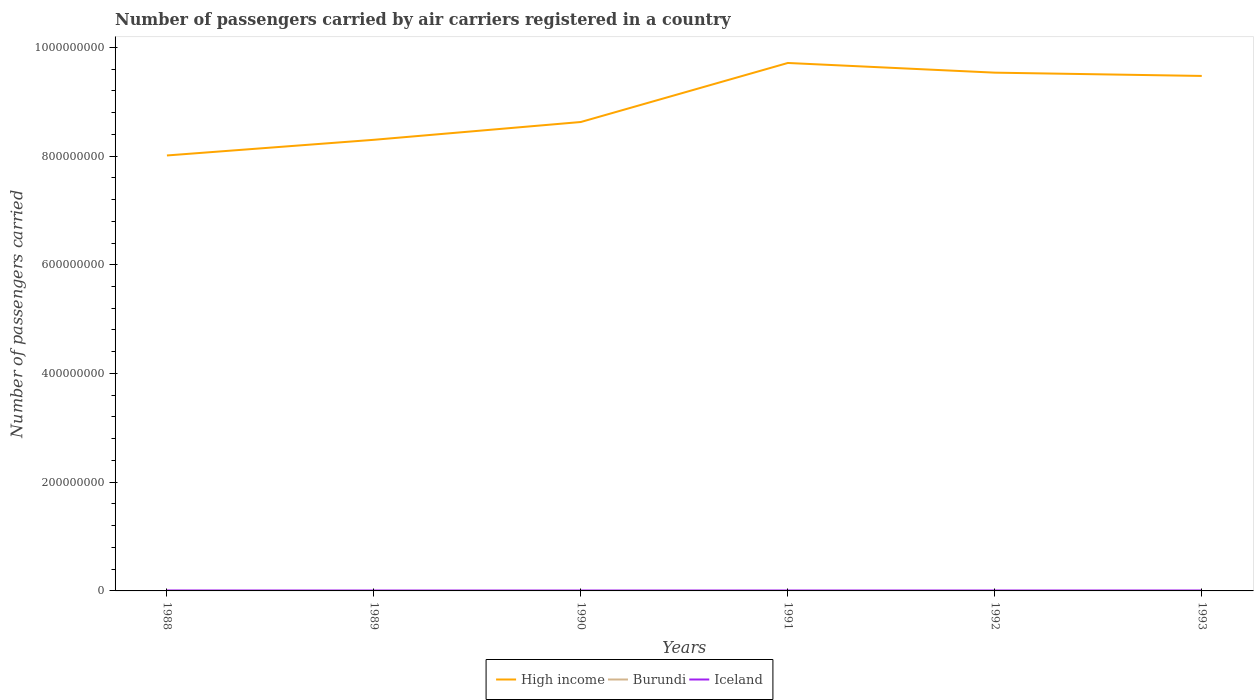Across all years, what is the maximum number of passengers carried by air carriers in Burundi?
Ensure brevity in your answer.  7800. In which year was the number of passengers carried by air carriers in High income maximum?
Make the answer very short. 1988. What is the total number of passengers carried by air carriers in High income in the graph?
Provide a succinct answer. -1.23e+08. What is the difference between the highest and the second highest number of passengers carried by air carriers in Iceland?
Offer a very short reply. 1.09e+05. Is the number of passengers carried by air carriers in Burundi strictly greater than the number of passengers carried by air carriers in Iceland over the years?
Offer a terse response. Yes. How many lines are there?
Your response must be concise. 3. What is the difference between two consecutive major ticks on the Y-axis?
Offer a terse response. 2.00e+08. What is the title of the graph?
Provide a short and direct response. Number of passengers carried by air carriers registered in a country. What is the label or title of the Y-axis?
Your response must be concise. Number of passengers carried. What is the Number of passengers carried of High income in 1988?
Offer a terse response. 8.01e+08. What is the Number of passengers carried in Burundi in 1988?
Provide a succinct answer. 1.12e+04. What is the Number of passengers carried in Iceland in 1988?
Offer a terse response. 8.45e+05. What is the Number of passengers carried in High income in 1989?
Give a very brief answer. 8.30e+08. What is the Number of passengers carried in Burundi in 1989?
Your answer should be very brief. 7800. What is the Number of passengers carried of Iceland in 1989?
Offer a terse response. 7.36e+05. What is the Number of passengers carried in High income in 1990?
Make the answer very short. 8.63e+08. What is the Number of passengers carried in Burundi in 1990?
Keep it short and to the point. 8300. What is the Number of passengers carried in Iceland in 1990?
Provide a succinct answer. 7.60e+05. What is the Number of passengers carried in High income in 1991?
Offer a terse response. 9.71e+08. What is the Number of passengers carried in Burundi in 1991?
Your answer should be compact. 8300. What is the Number of passengers carried of Iceland in 1991?
Make the answer very short. 7.73e+05. What is the Number of passengers carried in High income in 1992?
Keep it short and to the point. 9.53e+08. What is the Number of passengers carried in Burundi in 1992?
Keep it short and to the point. 8900. What is the Number of passengers carried of Iceland in 1992?
Ensure brevity in your answer.  7.67e+05. What is the Number of passengers carried of High income in 1993?
Provide a succinct answer. 9.47e+08. What is the Number of passengers carried in Burundi in 1993?
Ensure brevity in your answer.  8900. What is the Number of passengers carried of Iceland in 1993?
Make the answer very short. 8.01e+05. Across all years, what is the maximum Number of passengers carried in High income?
Provide a short and direct response. 9.71e+08. Across all years, what is the maximum Number of passengers carried in Burundi?
Provide a succinct answer. 1.12e+04. Across all years, what is the maximum Number of passengers carried of Iceland?
Keep it short and to the point. 8.45e+05. Across all years, what is the minimum Number of passengers carried of High income?
Your answer should be very brief. 8.01e+08. Across all years, what is the minimum Number of passengers carried in Burundi?
Your answer should be very brief. 7800. Across all years, what is the minimum Number of passengers carried in Iceland?
Provide a succinct answer. 7.36e+05. What is the total Number of passengers carried of High income in the graph?
Provide a succinct answer. 5.37e+09. What is the total Number of passengers carried in Burundi in the graph?
Offer a terse response. 5.34e+04. What is the total Number of passengers carried in Iceland in the graph?
Give a very brief answer. 4.68e+06. What is the difference between the Number of passengers carried of High income in 1988 and that in 1989?
Offer a very short reply. -2.88e+07. What is the difference between the Number of passengers carried of Burundi in 1988 and that in 1989?
Your response must be concise. 3400. What is the difference between the Number of passengers carried of Iceland in 1988 and that in 1989?
Offer a terse response. 1.09e+05. What is the difference between the Number of passengers carried of High income in 1988 and that in 1990?
Provide a succinct answer. -6.16e+07. What is the difference between the Number of passengers carried of Burundi in 1988 and that in 1990?
Offer a terse response. 2900. What is the difference between the Number of passengers carried in Iceland in 1988 and that in 1990?
Offer a very short reply. 8.52e+04. What is the difference between the Number of passengers carried of High income in 1988 and that in 1991?
Offer a terse response. -1.70e+08. What is the difference between the Number of passengers carried in Burundi in 1988 and that in 1991?
Give a very brief answer. 2900. What is the difference between the Number of passengers carried in Iceland in 1988 and that in 1991?
Your answer should be very brief. 7.21e+04. What is the difference between the Number of passengers carried in High income in 1988 and that in 1992?
Your response must be concise. -1.52e+08. What is the difference between the Number of passengers carried of Burundi in 1988 and that in 1992?
Your answer should be very brief. 2300. What is the difference between the Number of passengers carried in Iceland in 1988 and that in 1992?
Provide a short and direct response. 7.76e+04. What is the difference between the Number of passengers carried in High income in 1988 and that in 1993?
Provide a succinct answer. -1.46e+08. What is the difference between the Number of passengers carried in Burundi in 1988 and that in 1993?
Your answer should be compact. 2300. What is the difference between the Number of passengers carried in Iceland in 1988 and that in 1993?
Your answer should be compact. 4.37e+04. What is the difference between the Number of passengers carried in High income in 1989 and that in 1990?
Provide a succinct answer. -3.27e+07. What is the difference between the Number of passengers carried in Burundi in 1989 and that in 1990?
Provide a short and direct response. -500. What is the difference between the Number of passengers carried of Iceland in 1989 and that in 1990?
Offer a very short reply. -2.36e+04. What is the difference between the Number of passengers carried of High income in 1989 and that in 1991?
Your answer should be compact. -1.41e+08. What is the difference between the Number of passengers carried in Burundi in 1989 and that in 1991?
Provide a succinct answer. -500. What is the difference between the Number of passengers carried in Iceland in 1989 and that in 1991?
Provide a short and direct response. -3.67e+04. What is the difference between the Number of passengers carried of High income in 1989 and that in 1992?
Your answer should be very brief. -1.23e+08. What is the difference between the Number of passengers carried in Burundi in 1989 and that in 1992?
Offer a terse response. -1100. What is the difference between the Number of passengers carried in Iceland in 1989 and that in 1992?
Keep it short and to the point. -3.12e+04. What is the difference between the Number of passengers carried of High income in 1989 and that in 1993?
Offer a very short reply. -1.17e+08. What is the difference between the Number of passengers carried of Burundi in 1989 and that in 1993?
Make the answer very short. -1100. What is the difference between the Number of passengers carried of Iceland in 1989 and that in 1993?
Your answer should be compact. -6.51e+04. What is the difference between the Number of passengers carried of High income in 1990 and that in 1991?
Keep it short and to the point. -1.09e+08. What is the difference between the Number of passengers carried in Burundi in 1990 and that in 1991?
Ensure brevity in your answer.  0. What is the difference between the Number of passengers carried of Iceland in 1990 and that in 1991?
Your answer should be very brief. -1.31e+04. What is the difference between the Number of passengers carried in High income in 1990 and that in 1992?
Make the answer very short. -9.08e+07. What is the difference between the Number of passengers carried of Burundi in 1990 and that in 1992?
Offer a terse response. -600. What is the difference between the Number of passengers carried of Iceland in 1990 and that in 1992?
Provide a short and direct response. -7600. What is the difference between the Number of passengers carried of High income in 1990 and that in 1993?
Offer a terse response. -8.47e+07. What is the difference between the Number of passengers carried of Burundi in 1990 and that in 1993?
Provide a short and direct response. -600. What is the difference between the Number of passengers carried in Iceland in 1990 and that in 1993?
Your answer should be compact. -4.15e+04. What is the difference between the Number of passengers carried of High income in 1991 and that in 1992?
Your answer should be compact. 1.78e+07. What is the difference between the Number of passengers carried of Burundi in 1991 and that in 1992?
Your response must be concise. -600. What is the difference between the Number of passengers carried in Iceland in 1991 and that in 1992?
Provide a succinct answer. 5500. What is the difference between the Number of passengers carried in High income in 1991 and that in 1993?
Your answer should be very brief. 2.39e+07. What is the difference between the Number of passengers carried in Burundi in 1991 and that in 1993?
Offer a terse response. -600. What is the difference between the Number of passengers carried of Iceland in 1991 and that in 1993?
Offer a very short reply. -2.84e+04. What is the difference between the Number of passengers carried in High income in 1992 and that in 1993?
Your response must be concise. 6.03e+06. What is the difference between the Number of passengers carried in Iceland in 1992 and that in 1993?
Your response must be concise. -3.39e+04. What is the difference between the Number of passengers carried in High income in 1988 and the Number of passengers carried in Burundi in 1989?
Offer a terse response. 8.01e+08. What is the difference between the Number of passengers carried in High income in 1988 and the Number of passengers carried in Iceland in 1989?
Make the answer very short. 8.00e+08. What is the difference between the Number of passengers carried of Burundi in 1988 and the Number of passengers carried of Iceland in 1989?
Ensure brevity in your answer.  -7.25e+05. What is the difference between the Number of passengers carried of High income in 1988 and the Number of passengers carried of Burundi in 1990?
Offer a very short reply. 8.01e+08. What is the difference between the Number of passengers carried of High income in 1988 and the Number of passengers carried of Iceland in 1990?
Your response must be concise. 8.00e+08. What is the difference between the Number of passengers carried in Burundi in 1988 and the Number of passengers carried in Iceland in 1990?
Ensure brevity in your answer.  -7.48e+05. What is the difference between the Number of passengers carried in High income in 1988 and the Number of passengers carried in Burundi in 1991?
Give a very brief answer. 8.01e+08. What is the difference between the Number of passengers carried of High income in 1988 and the Number of passengers carried of Iceland in 1991?
Provide a succinct answer. 8.00e+08. What is the difference between the Number of passengers carried in Burundi in 1988 and the Number of passengers carried in Iceland in 1991?
Give a very brief answer. -7.61e+05. What is the difference between the Number of passengers carried in High income in 1988 and the Number of passengers carried in Burundi in 1992?
Your answer should be compact. 8.01e+08. What is the difference between the Number of passengers carried of High income in 1988 and the Number of passengers carried of Iceland in 1992?
Ensure brevity in your answer.  8.00e+08. What is the difference between the Number of passengers carried in Burundi in 1988 and the Number of passengers carried in Iceland in 1992?
Provide a succinct answer. -7.56e+05. What is the difference between the Number of passengers carried of High income in 1988 and the Number of passengers carried of Burundi in 1993?
Make the answer very short. 8.01e+08. What is the difference between the Number of passengers carried in High income in 1988 and the Number of passengers carried in Iceland in 1993?
Provide a succinct answer. 8.00e+08. What is the difference between the Number of passengers carried of Burundi in 1988 and the Number of passengers carried of Iceland in 1993?
Keep it short and to the point. -7.90e+05. What is the difference between the Number of passengers carried of High income in 1989 and the Number of passengers carried of Burundi in 1990?
Your response must be concise. 8.30e+08. What is the difference between the Number of passengers carried of High income in 1989 and the Number of passengers carried of Iceland in 1990?
Keep it short and to the point. 8.29e+08. What is the difference between the Number of passengers carried of Burundi in 1989 and the Number of passengers carried of Iceland in 1990?
Provide a short and direct response. -7.52e+05. What is the difference between the Number of passengers carried of High income in 1989 and the Number of passengers carried of Burundi in 1991?
Offer a very short reply. 8.30e+08. What is the difference between the Number of passengers carried in High income in 1989 and the Number of passengers carried in Iceland in 1991?
Offer a very short reply. 8.29e+08. What is the difference between the Number of passengers carried of Burundi in 1989 and the Number of passengers carried of Iceland in 1991?
Ensure brevity in your answer.  -7.65e+05. What is the difference between the Number of passengers carried in High income in 1989 and the Number of passengers carried in Burundi in 1992?
Your answer should be very brief. 8.30e+08. What is the difference between the Number of passengers carried in High income in 1989 and the Number of passengers carried in Iceland in 1992?
Provide a succinct answer. 8.29e+08. What is the difference between the Number of passengers carried in Burundi in 1989 and the Number of passengers carried in Iceland in 1992?
Ensure brevity in your answer.  -7.59e+05. What is the difference between the Number of passengers carried of High income in 1989 and the Number of passengers carried of Burundi in 1993?
Make the answer very short. 8.30e+08. What is the difference between the Number of passengers carried in High income in 1989 and the Number of passengers carried in Iceland in 1993?
Your response must be concise. 8.29e+08. What is the difference between the Number of passengers carried in Burundi in 1989 and the Number of passengers carried in Iceland in 1993?
Give a very brief answer. -7.93e+05. What is the difference between the Number of passengers carried of High income in 1990 and the Number of passengers carried of Burundi in 1991?
Your answer should be very brief. 8.63e+08. What is the difference between the Number of passengers carried of High income in 1990 and the Number of passengers carried of Iceland in 1991?
Your response must be concise. 8.62e+08. What is the difference between the Number of passengers carried in Burundi in 1990 and the Number of passengers carried in Iceland in 1991?
Offer a terse response. -7.64e+05. What is the difference between the Number of passengers carried of High income in 1990 and the Number of passengers carried of Burundi in 1992?
Make the answer very short. 8.63e+08. What is the difference between the Number of passengers carried of High income in 1990 and the Number of passengers carried of Iceland in 1992?
Ensure brevity in your answer.  8.62e+08. What is the difference between the Number of passengers carried of Burundi in 1990 and the Number of passengers carried of Iceland in 1992?
Ensure brevity in your answer.  -7.59e+05. What is the difference between the Number of passengers carried of High income in 1990 and the Number of passengers carried of Burundi in 1993?
Ensure brevity in your answer.  8.63e+08. What is the difference between the Number of passengers carried in High income in 1990 and the Number of passengers carried in Iceland in 1993?
Provide a succinct answer. 8.62e+08. What is the difference between the Number of passengers carried of Burundi in 1990 and the Number of passengers carried of Iceland in 1993?
Your answer should be very brief. -7.93e+05. What is the difference between the Number of passengers carried of High income in 1991 and the Number of passengers carried of Burundi in 1992?
Give a very brief answer. 9.71e+08. What is the difference between the Number of passengers carried of High income in 1991 and the Number of passengers carried of Iceland in 1992?
Your answer should be very brief. 9.70e+08. What is the difference between the Number of passengers carried of Burundi in 1991 and the Number of passengers carried of Iceland in 1992?
Your answer should be very brief. -7.59e+05. What is the difference between the Number of passengers carried of High income in 1991 and the Number of passengers carried of Burundi in 1993?
Keep it short and to the point. 9.71e+08. What is the difference between the Number of passengers carried in High income in 1991 and the Number of passengers carried in Iceland in 1993?
Keep it short and to the point. 9.70e+08. What is the difference between the Number of passengers carried of Burundi in 1991 and the Number of passengers carried of Iceland in 1993?
Offer a very short reply. -7.93e+05. What is the difference between the Number of passengers carried of High income in 1992 and the Number of passengers carried of Burundi in 1993?
Offer a very short reply. 9.53e+08. What is the difference between the Number of passengers carried in High income in 1992 and the Number of passengers carried in Iceland in 1993?
Ensure brevity in your answer.  9.53e+08. What is the difference between the Number of passengers carried in Burundi in 1992 and the Number of passengers carried in Iceland in 1993?
Offer a very short reply. -7.92e+05. What is the average Number of passengers carried in High income per year?
Offer a very short reply. 8.94e+08. What is the average Number of passengers carried of Burundi per year?
Offer a terse response. 8900. What is the average Number of passengers carried of Iceland per year?
Keep it short and to the point. 7.80e+05. In the year 1988, what is the difference between the Number of passengers carried of High income and Number of passengers carried of Burundi?
Keep it short and to the point. 8.01e+08. In the year 1988, what is the difference between the Number of passengers carried of High income and Number of passengers carried of Iceland?
Your response must be concise. 8.00e+08. In the year 1988, what is the difference between the Number of passengers carried of Burundi and Number of passengers carried of Iceland?
Provide a succinct answer. -8.34e+05. In the year 1989, what is the difference between the Number of passengers carried of High income and Number of passengers carried of Burundi?
Offer a very short reply. 8.30e+08. In the year 1989, what is the difference between the Number of passengers carried in High income and Number of passengers carried in Iceland?
Ensure brevity in your answer.  8.29e+08. In the year 1989, what is the difference between the Number of passengers carried of Burundi and Number of passengers carried of Iceland?
Make the answer very short. -7.28e+05. In the year 1990, what is the difference between the Number of passengers carried in High income and Number of passengers carried in Burundi?
Ensure brevity in your answer.  8.63e+08. In the year 1990, what is the difference between the Number of passengers carried in High income and Number of passengers carried in Iceland?
Your response must be concise. 8.62e+08. In the year 1990, what is the difference between the Number of passengers carried in Burundi and Number of passengers carried in Iceland?
Keep it short and to the point. -7.51e+05. In the year 1991, what is the difference between the Number of passengers carried in High income and Number of passengers carried in Burundi?
Make the answer very short. 9.71e+08. In the year 1991, what is the difference between the Number of passengers carried in High income and Number of passengers carried in Iceland?
Give a very brief answer. 9.70e+08. In the year 1991, what is the difference between the Number of passengers carried in Burundi and Number of passengers carried in Iceland?
Your response must be concise. -7.64e+05. In the year 1992, what is the difference between the Number of passengers carried in High income and Number of passengers carried in Burundi?
Ensure brevity in your answer.  9.53e+08. In the year 1992, what is the difference between the Number of passengers carried of High income and Number of passengers carried of Iceland?
Your response must be concise. 9.53e+08. In the year 1992, what is the difference between the Number of passengers carried in Burundi and Number of passengers carried in Iceland?
Offer a very short reply. -7.58e+05. In the year 1993, what is the difference between the Number of passengers carried of High income and Number of passengers carried of Burundi?
Offer a very short reply. 9.47e+08. In the year 1993, what is the difference between the Number of passengers carried of High income and Number of passengers carried of Iceland?
Your answer should be compact. 9.47e+08. In the year 1993, what is the difference between the Number of passengers carried in Burundi and Number of passengers carried in Iceland?
Provide a short and direct response. -7.92e+05. What is the ratio of the Number of passengers carried of High income in 1988 to that in 1989?
Ensure brevity in your answer.  0.97. What is the ratio of the Number of passengers carried in Burundi in 1988 to that in 1989?
Provide a short and direct response. 1.44. What is the ratio of the Number of passengers carried of Iceland in 1988 to that in 1989?
Make the answer very short. 1.15. What is the ratio of the Number of passengers carried of Burundi in 1988 to that in 1990?
Offer a terse response. 1.35. What is the ratio of the Number of passengers carried in Iceland in 1988 to that in 1990?
Your response must be concise. 1.11. What is the ratio of the Number of passengers carried of High income in 1988 to that in 1991?
Offer a terse response. 0.82. What is the ratio of the Number of passengers carried of Burundi in 1988 to that in 1991?
Provide a short and direct response. 1.35. What is the ratio of the Number of passengers carried of Iceland in 1988 to that in 1991?
Give a very brief answer. 1.09. What is the ratio of the Number of passengers carried of High income in 1988 to that in 1992?
Offer a very short reply. 0.84. What is the ratio of the Number of passengers carried of Burundi in 1988 to that in 1992?
Give a very brief answer. 1.26. What is the ratio of the Number of passengers carried of Iceland in 1988 to that in 1992?
Your response must be concise. 1.1. What is the ratio of the Number of passengers carried in High income in 1988 to that in 1993?
Offer a very short reply. 0.85. What is the ratio of the Number of passengers carried in Burundi in 1988 to that in 1993?
Your answer should be very brief. 1.26. What is the ratio of the Number of passengers carried in Iceland in 1988 to that in 1993?
Your response must be concise. 1.05. What is the ratio of the Number of passengers carried in Burundi in 1989 to that in 1990?
Make the answer very short. 0.94. What is the ratio of the Number of passengers carried of Iceland in 1989 to that in 1990?
Offer a very short reply. 0.97. What is the ratio of the Number of passengers carried of High income in 1989 to that in 1991?
Provide a short and direct response. 0.85. What is the ratio of the Number of passengers carried in Burundi in 1989 to that in 1991?
Ensure brevity in your answer.  0.94. What is the ratio of the Number of passengers carried of Iceland in 1989 to that in 1991?
Offer a terse response. 0.95. What is the ratio of the Number of passengers carried in High income in 1989 to that in 1992?
Make the answer very short. 0.87. What is the ratio of the Number of passengers carried of Burundi in 1989 to that in 1992?
Provide a short and direct response. 0.88. What is the ratio of the Number of passengers carried of Iceland in 1989 to that in 1992?
Your answer should be very brief. 0.96. What is the ratio of the Number of passengers carried in High income in 1989 to that in 1993?
Your answer should be compact. 0.88. What is the ratio of the Number of passengers carried of Burundi in 1989 to that in 1993?
Make the answer very short. 0.88. What is the ratio of the Number of passengers carried of Iceland in 1989 to that in 1993?
Your answer should be very brief. 0.92. What is the ratio of the Number of passengers carried of High income in 1990 to that in 1991?
Provide a short and direct response. 0.89. What is the ratio of the Number of passengers carried of High income in 1990 to that in 1992?
Keep it short and to the point. 0.9. What is the ratio of the Number of passengers carried in Burundi in 1990 to that in 1992?
Keep it short and to the point. 0.93. What is the ratio of the Number of passengers carried of High income in 1990 to that in 1993?
Your response must be concise. 0.91. What is the ratio of the Number of passengers carried in Burundi in 1990 to that in 1993?
Offer a very short reply. 0.93. What is the ratio of the Number of passengers carried in Iceland in 1990 to that in 1993?
Offer a very short reply. 0.95. What is the ratio of the Number of passengers carried in High income in 1991 to that in 1992?
Make the answer very short. 1.02. What is the ratio of the Number of passengers carried in Burundi in 1991 to that in 1992?
Provide a succinct answer. 0.93. What is the ratio of the Number of passengers carried of Iceland in 1991 to that in 1992?
Ensure brevity in your answer.  1.01. What is the ratio of the Number of passengers carried of High income in 1991 to that in 1993?
Your response must be concise. 1.03. What is the ratio of the Number of passengers carried of Burundi in 1991 to that in 1993?
Provide a short and direct response. 0.93. What is the ratio of the Number of passengers carried of Iceland in 1991 to that in 1993?
Ensure brevity in your answer.  0.96. What is the ratio of the Number of passengers carried of High income in 1992 to that in 1993?
Your answer should be very brief. 1.01. What is the ratio of the Number of passengers carried in Iceland in 1992 to that in 1993?
Provide a short and direct response. 0.96. What is the difference between the highest and the second highest Number of passengers carried in High income?
Offer a very short reply. 1.78e+07. What is the difference between the highest and the second highest Number of passengers carried of Burundi?
Provide a succinct answer. 2300. What is the difference between the highest and the second highest Number of passengers carried of Iceland?
Offer a very short reply. 4.37e+04. What is the difference between the highest and the lowest Number of passengers carried in High income?
Your response must be concise. 1.70e+08. What is the difference between the highest and the lowest Number of passengers carried in Burundi?
Keep it short and to the point. 3400. What is the difference between the highest and the lowest Number of passengers carried in Iceland?
Provide a succinct answer. 1.09e+05. 